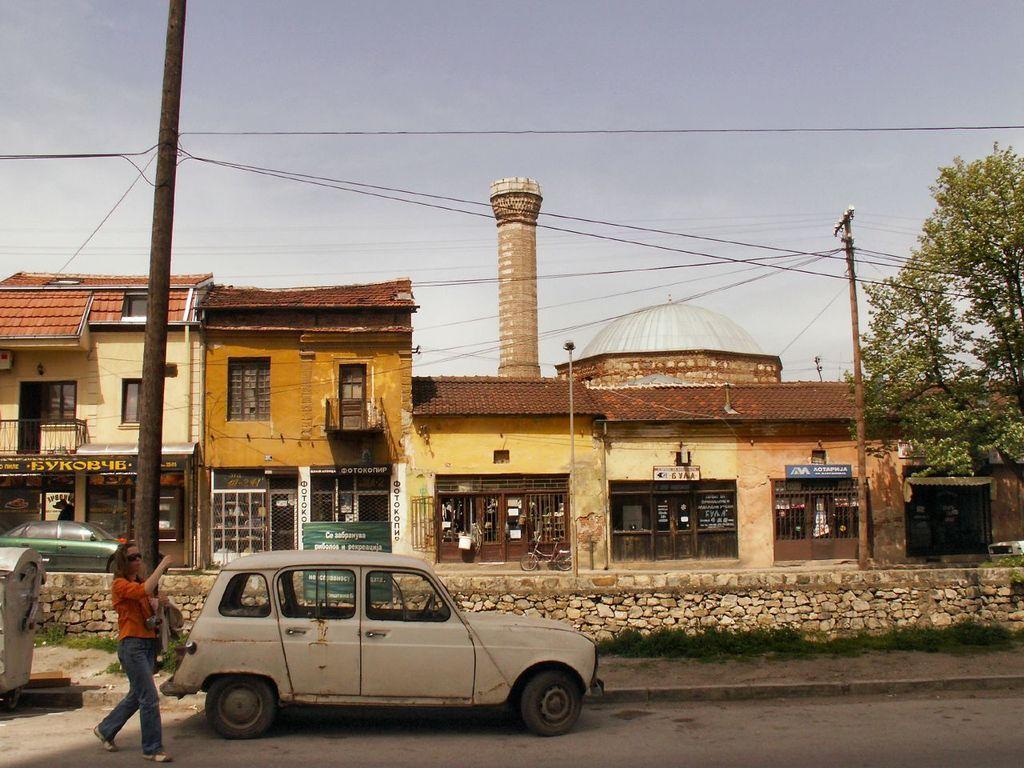In one or two sentences, can you explain what this image depicts? This image is taken outdoors. At the top of the image there is a sky with clouds. At the bottom of the image there is a road. In the middle of the image there are a few houses with walls, windows, doors, roofs, a railing and a balcony. There are many boards with text on them. There is a tower. There are two poles with wires and a street light. On the right side of the image there is a tree. In the middle of the image a car is parked on the road and a woman is walking on the road. On the left side of the image a car is parked on the ground and there is a transformer. 